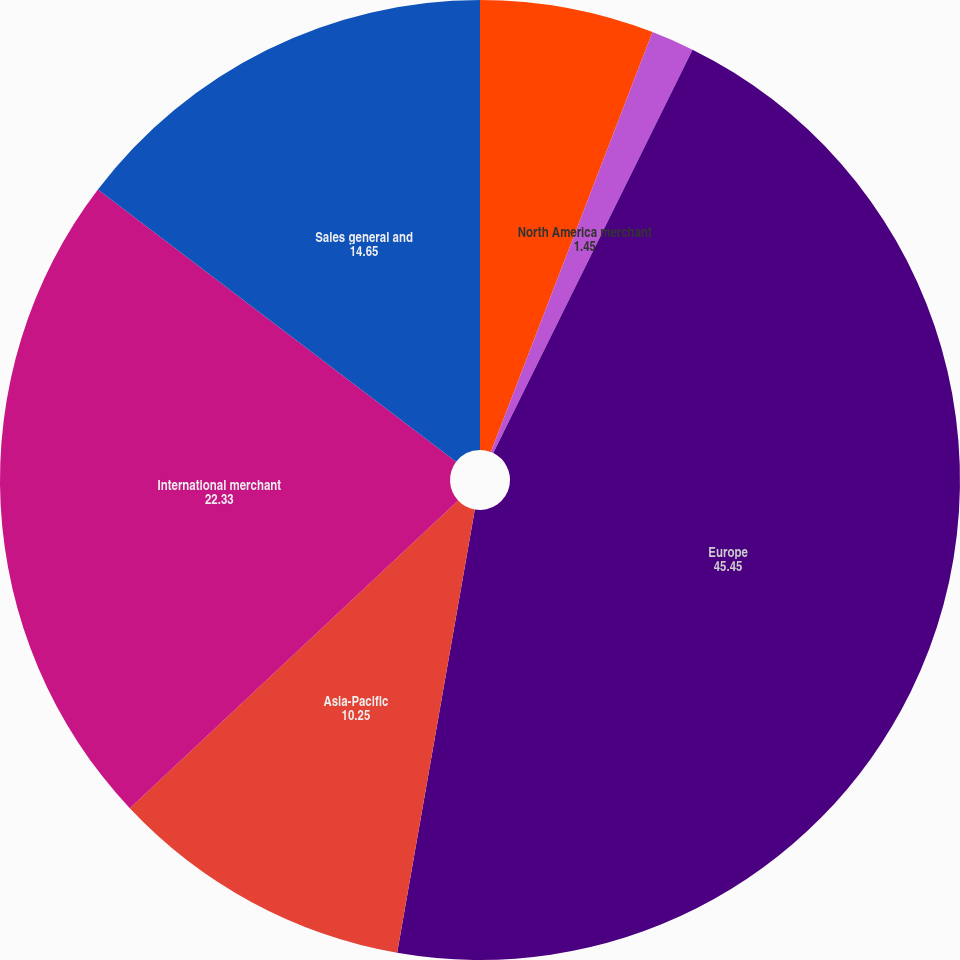Convert chart to OTSL. <chart><loc_0><loc_0><loc_500><loc_500><pie_chart><fcel>Canada<fcel>North America merchant<fcel>Europe<fcel>Asia-Pacific<fcel>International merchant<fcel>Sales general and<nl><fcel>5.85%<fcel>1.45%<fcel>45.45%<fcel>10.25%<fcel>22.33%<fcel>14.65%<nl></chart> 